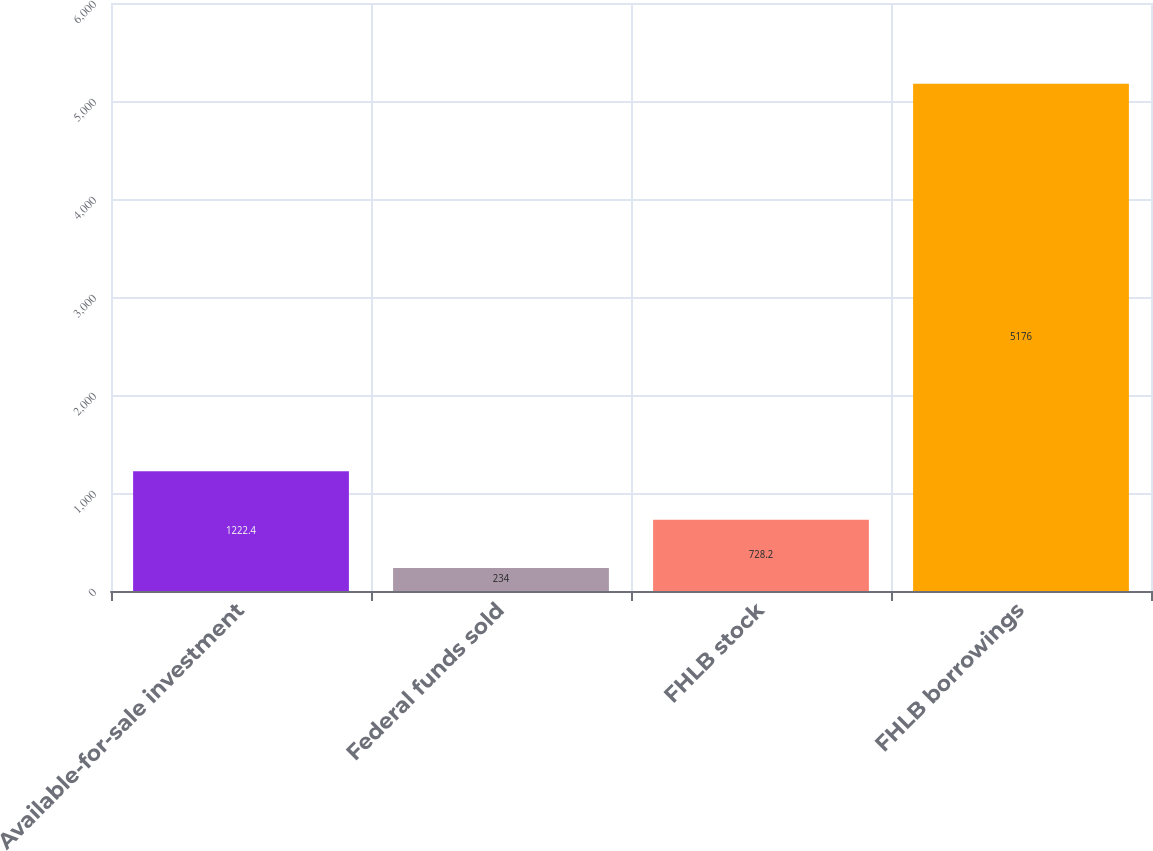Convert chart. <chart><loc_0><loc_0><loc_500><loc_500><bar_chart><fcel>Available-for-sale investment<fcel>Federal funds sold<fcel>FHLB stock<fcel>FHLB borrowings<nl><fcel>1222.4<fcel>234<fcel>728.2<fcel>5176<nl></chart> 